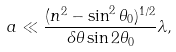<formula> <loc_0><loc_0><loc_500><loc_500>a \ll \frac { ( n ^ { 2 } - \sin ^ { 2 } \theta _ { 0 } ) ^ { 1 / 2 } } { \delta \theta \sin 2 \theta _ { 0 } } \lambda ,</formula> 